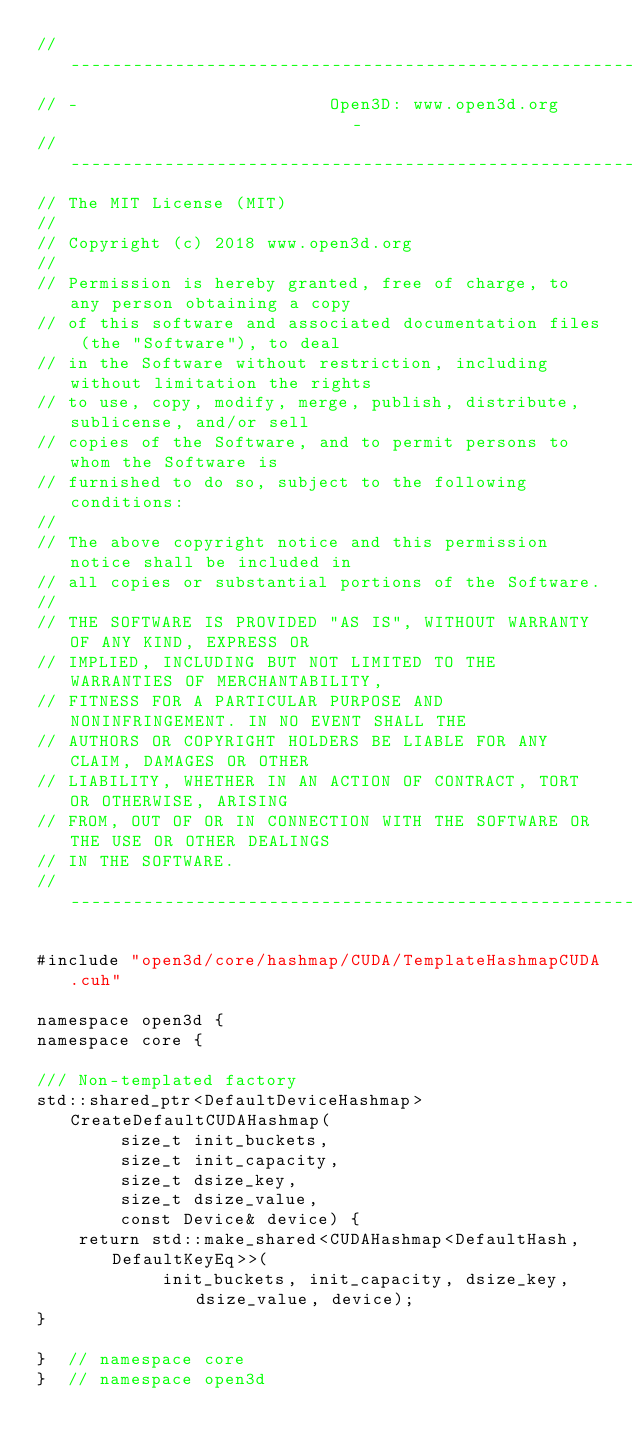<code> <loc_0><loc_0><loc_500><loc_500><_Cuda_>// ----------------------------------------------------------------------------
// -                        Open3D: www.open3d.org                            -
// ----------------------------------------------------------------------------
// The MIT License (MIT)
//
// Copyright (c) 2018 www.open3d.org
//
// Permission is hereby granted, free of charge, to any person obtaining a copy
// of this software and associated documentation files (the "Software"), to deal
// in the Software without restriction, including without limitation the rights
// to use, copy, modify, merge, publish, distribute, sublicense, and/or sell
// copies of the Software, and to permit persons to whom the Software is
// furnished to do so, subject to the following conditions:
//
// The above copyright notice and this permission notice shall be included in
// all copies or substantial portions of the Software.
//
// THE SOFTWARE IS PROVIDED "AS IS", WITHOUT WARRANTY OF ANY KIND, EXPRESS OR
// IMPLIED, INCLUDING BUT NOT LIMITED TO THE WARRANTIES OF MERCHANTABILITY,
// FITNESS FOR A PARTICULAR PURPOSE AND NONINFRINGEMENT. IN NO EVENT SHALL THE
// AUTHORS OR COPYRIGHT HOLDERS BE LIABLE FOR ANY CLAIM, DAMAGES OR OTHER
// LIABILITY, WHETHER IN AN ACTION OF CONTRACT, TORT OR OTHERWISE, ARISING
// FROM, OUT OF OR IN CONNECTION WITH THE SOFTWARE OR THE USE OR OTHER DEALINGS
// IN THE SOFTWARE.
// ----------------------------------------------------------------------------

#include "open3d/core/hashmap/CUDA/TemplateHashmapCUDA.cuh"

namespace open3d {
namespace core {

/// Non-templated factory
std::shared_ptr<DefaultDeviceHashmap> CreateDefaultCUDAHashmap(
        size_t init_buckets,
        size_t init_capacity,
        size_t dsize_key,
        size_t dsize_value,
        const Device& device) {
    return std::make_shared<CUDAHashmap<DefaultHash, DefaultKeyEq>>(
            init_buckets, init_capacity, dsize_key, dsize_value, device);
}

}  // namespace core
}  // namespace open3d
</code> 